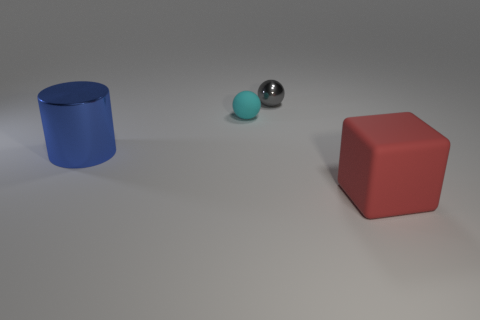Add 3 gray metallic balls. How many objects exist? 7 Subtract all blocks. How many objects are left? 3 Add 2 gray shiny balls. How many gray shiny balls are left? 3 Add 1 blue cylinders. How many blue cylinders exist? 2 Subtract 0 purple balls. How many objects are left? 4 Subtract all small purple metallic things. Subtract all small cyan rubber spheres. How many objects are left? 3 